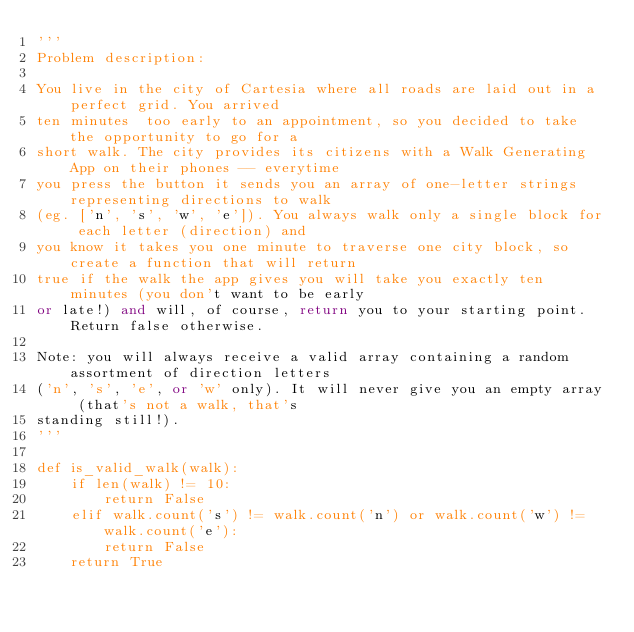<code> <loc_0><loc_0><loc_500><loc_500><_Python_>'''
Problem description:

You live in the city of Cartesia where all roads are laid out in a perfect grid. You arrived 
ten minutes  too early to an appointment, so you decided to take the opportunity to go for a 
short walk. The city provides its citizens with a Walk Generating App on their phones -- everytime 
you press the button it sends you an array of one-letter strings representing directions to walk 
(eg. ['n', 's', 'w', 'e']). You always walk only a single block for each letter (direction) and 
you know it takes you one minute to traverse one city block, so create a function that will return
true if the walk the app gives you will take you exactly ten minutes (you don't want to be early 
or late!) and will, of course, return you to your starting point. Return false otherwise.

Note: you will always receive a valid array containing a random assortment of direction letters 
('n', 's', 'e', or 'w' only). It will never give you an empty array (that's not a walk, that's 
standing still!).
'''

def is_valid_walk(walk):
    if len(walk) != 10:
        return False
    elif walk.count('s') != walk.count('n') or walk.count('w') != walk.count('e'):
        return False
    return True</code> 